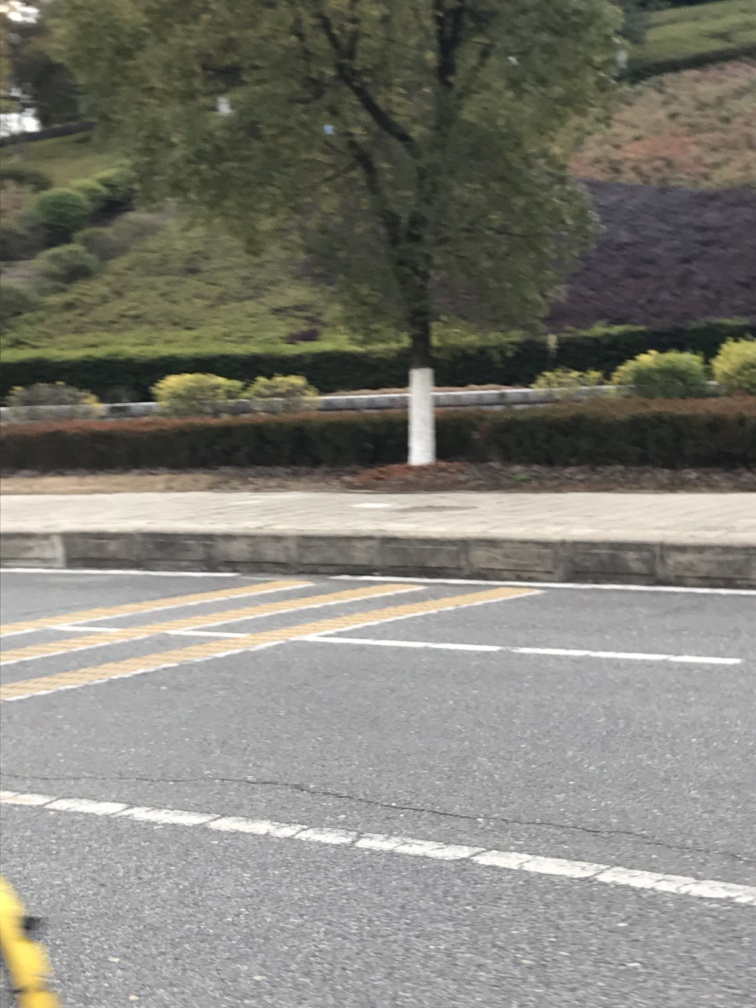Can you tell me more about the weather based on the image? The overcast skies and the absence of strong shadows suggest that the photo was taken on a cloudy day. The lighting is subdued, indicating that the sun is behind the clouds. 